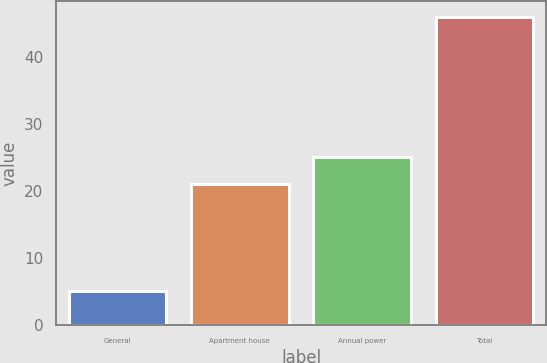Convert chart. <chart><loc_0><loc_0><loc_500><loc_500><bar_chart><fcel>General<fcel>Apartment house<fcel>Annual power<fcel>Total<nl><fcel>5<fcel>21<fcel>25.1<fcel>46<nl></chart> 